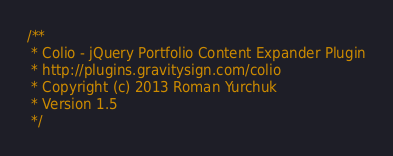<code> <loc_0><loc_0><loc_500><loc_500><_JavaScript_>/**
 * Colio - jQuery Portfolio Content Expander Plugin
 * http://plugins.gravitysign.com/colio
 * Copyright (c) 2013 Roman Yurchuk
 * Version 1.5
 */
</code> 